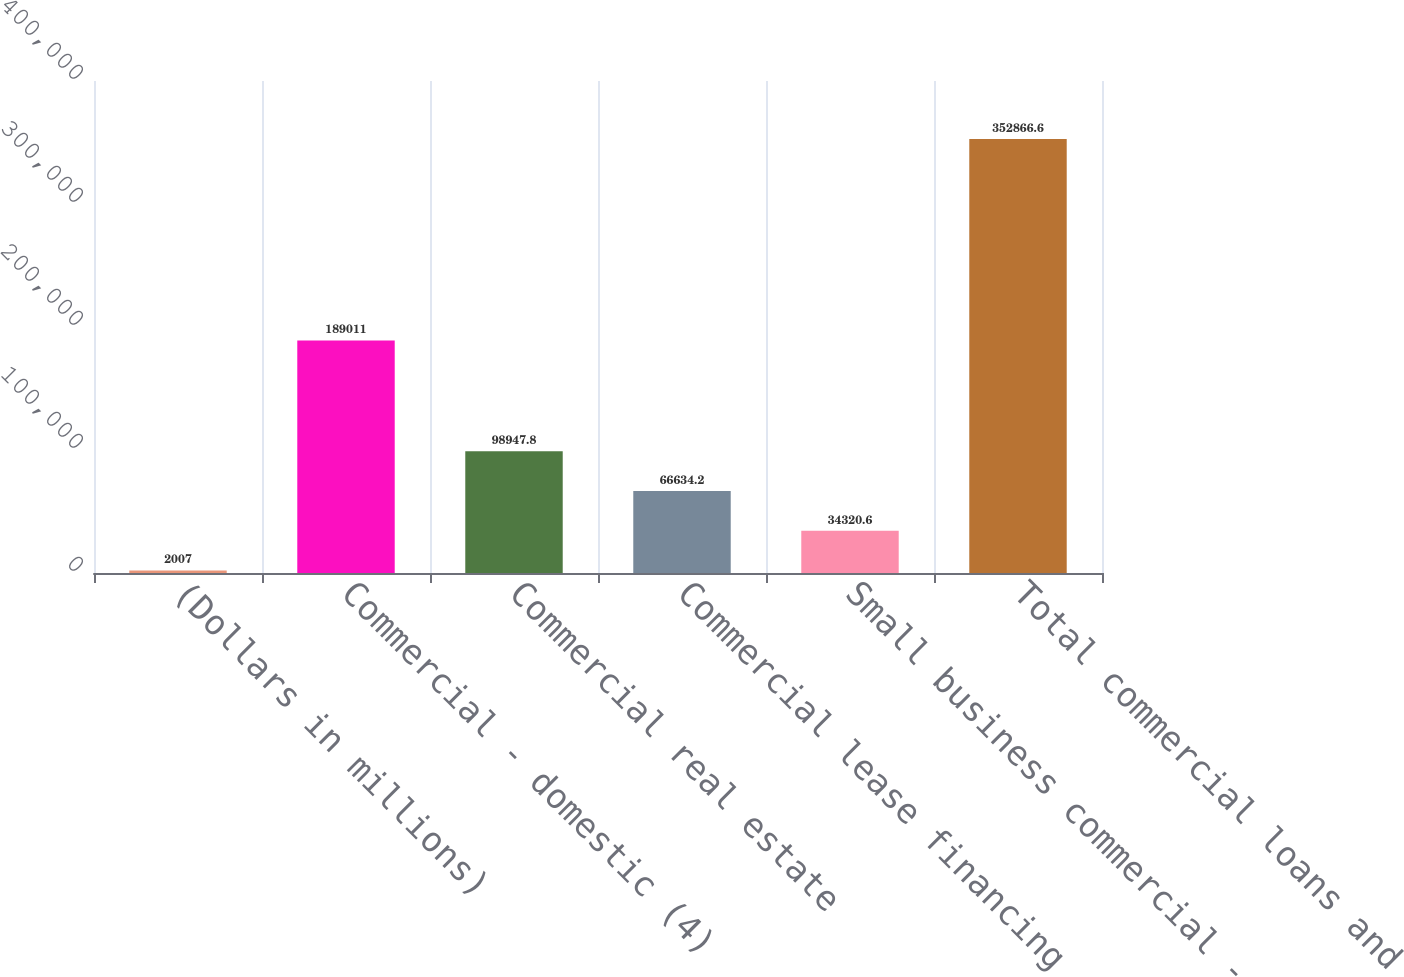Convert chart to OTSL. <chart><loc_0><loc_0><loc_500><loc_500><bar_chart><fcel>(Dollars in millions)<fcel>Commercial - domestic (4)<fcel>Commercial real estate<fcel>Commercial lease financing<fcel>Small business commercial -<fcel>Total commercial loans and<nl><fcel>2007<fcel>189011<fcel>98947.8<fcel>66634.2<fcel>34320.6<fcel>352867<nl></chart> 